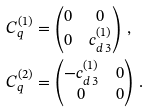<formula> <loc_0><loc_0><loc_500><loc_500>C ^ { ( 1 ) } _ { q } & = \begin{pmatrix} 0 & 0 \\ 0 & c ^ { ( 1 ) } _ { d \, 3 } \end{pmatrix} \, , \\ C ^ { ( 2 ) } _ { q } & = \begin{pmatrix} - c ^ { ( 1 ) } _ { d \, 3 } & 0 \\ 0 & 0 \end{pmatrix} \, .</formula> 